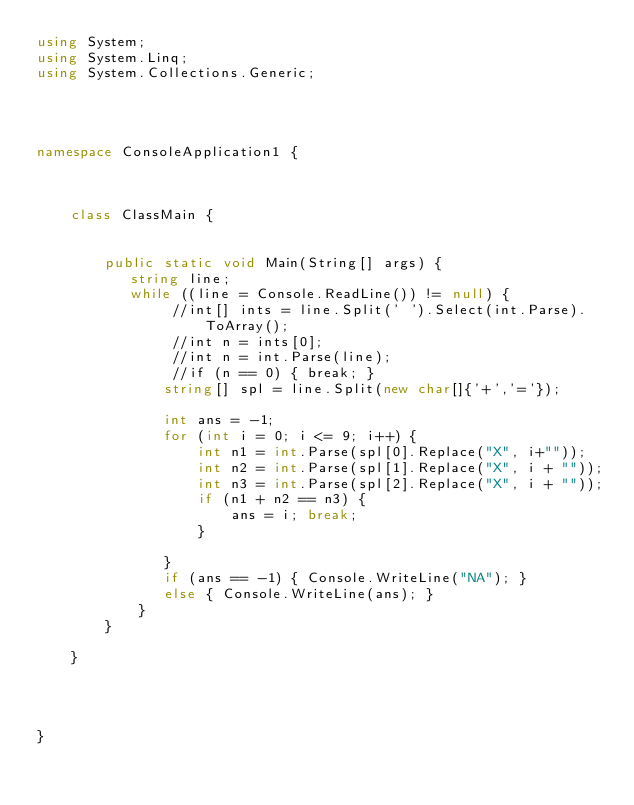<code> <loc_0><loc_0><loc_500><loc_500><_C#_>using System;
using System.Linq;
using System.Collections.Generic;




namespace ConsoleApplication1 {

    

    class ClassMain {


        public static void Main(String[] args) {
           string line;
           while ((line = Console.ReadLine()) != null) {
                //int[] ints = line.Split(' ').Select(int.Parse).ToArray();
                //int n = ints[0];
                //int n = int.Parse(line);                
                //if (n == 0) { break; }
               string[] spl = line.Split(new char[]{'+','='});

               int ans = -1;
               for (int i = 0; i <= 9; i++) {
                   int n1 = int.Parse(spl[0].Replace("X", i+""));
                   int n2 = int.Parse(spl[1].Replace("X", i + ""));
                   int n3 = int.Parse(spl[2].Replace("X", i + ""));
                   if (n1 + n2 == n3) {
                       ans = i; break;
                   }

               }
               if (ans == -1) { Console.WriteLine("NA"); }
               else { Console.WriteLine(ans); }               
            }
        }

    }

    


}</code> 